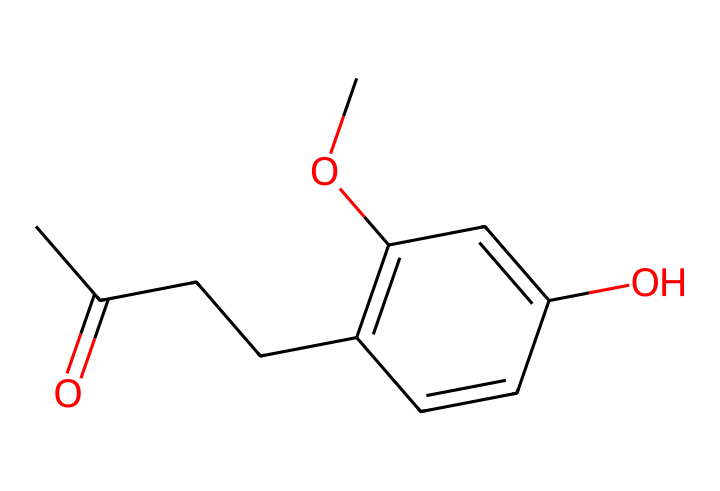What is the molecular formula of raspberry ketone? To determine the molecular formula, we identify the different atoms present in the chemical structure. Counting the carbon (C), hydrogen (H), and oxygen (O) atoms gives: 10 carbons, 10 hydrogens, and 2 oxygens, resulting in the molecular formula C10H10O2.
Answer: C10H10O2 How many double bonds are present in raspberry ketone? By analyzing the structure, we can identify the double bonds based on the carbon atom connectivity. The structure includes two double bonds between carbons in the aromatic ring and one double bond in the carbonyl group, for a total of three double bonds.
Answer: 3 What type of functional group is present in raspberry ketone? The structure shows a carbonyl group (C=O) associated with the ketone functional group. The carbonyl group within the overall structure indicates that this compound is a ketone.
Answer: ketone How many rings are present in the raspberry ketone structure? In examining the structure, we can observe that one ring is formed by the cyclic aromatic system of carbon atoms. This accounts for the only ring present in the molecule.
Answer: 1 What is the significance of the hydroxyl group in raspberry ketone? The hydroxyl group (-OH) is connected to one of the carbon atoms in the aromatic ring, contributing to the compound's flavor profile and additional properties such as solubility. This functional group plays a crucial role in the characteristics of the flavoring agent.
Answer: flavor profile and solubility What is the relationship of the carbon skeleton to the flavoring properties? The carbon skeleton of raspberry ketone, with its unique arrangement of double bonds and the presence of functional groups, contributes to its aromatic properties. The structure allows the compound to engage with taste receptors effectively, making it a popular flavoring agent.
Answer: aromatic properties 